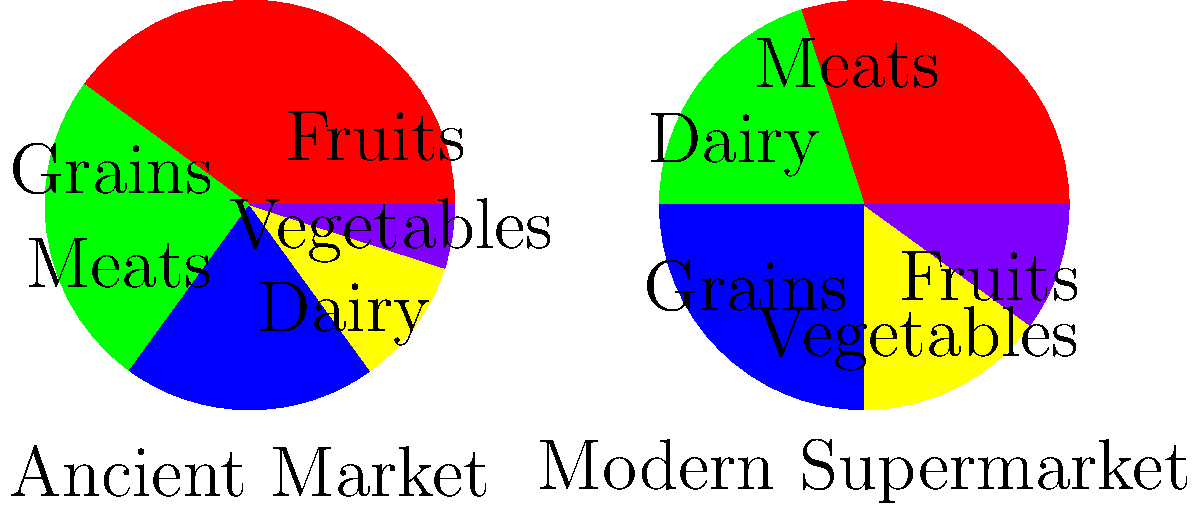Analyze the pie charts representing food distribution in ancient markets and modern supermarkets. Which food category shows the most significant increase in proportion from ancient markets to modern supermarkets? To answer this question, we need to compare the proportions of each food category between the ancient market and modern supermarket:

1. Grains:
   Ancient: 40%, Modern: 30%
   Change: -10% (decrease)

2. Fruits:
   Ancient: 25%, Modern: 20%
   Change: -5% (decrease)

3. Vegetables:
   Ancient: 20%, Modern: 25%
   Change: +5% (increase)

4. Meats:
   Ancient: 10%, Modern: 15%
   Change: +5% (increase)

5. Dairy:
   Ancient: 5%, Modern: 10%
   Change: +5% (increase)

Comparing the changes, we can see that Vegetables, Meats, and Dairy all show a 5% increase. However, the question asks for the "most significant increase," which can be interpreted as the largest relative increase.

To calculate the relative increase:
Vegetables: (25% - 20%) / 20% = 25% increase
Meats: (15% - 10%) / 10% = 50% increase
Dairy: (10% - 5%) / 5% = 100% increase

Therefore, the food category showing the most significant increase in proportion from ancient markets to modern supermarkets is Dairy, with a 100% relative increase.
Answer: Dairy 